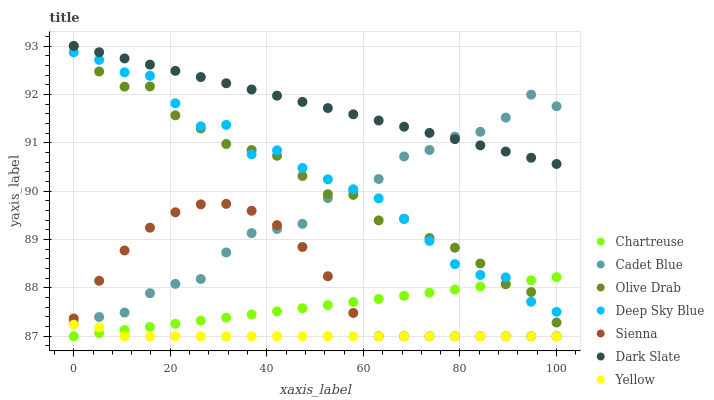Does Yellow have the minimum area under the curve?
Answer yes or no. Yes. Does Dark Slate have the maximum area under the curve?
Answer yes or no. Yes. Does Sienna have the minimum area under the curve?
Answer yes or no. No. Does Sienna have the maximum area under the curve?
Answer yes or no. No. Is Dark Slate the smoothest?
Answer yes or no. Yes. Is Olive Drab the roughest?
Answer yes or no. Yes. Is Yellow the smoothest?
Answer yes or no. No. Is Yellow the roughest?
Answer yes or no. No. Does Yellow have the lowest value?
Answer yes or no. Yes. Does Dark Slate have the lowest value?
Answer yes or no. No. Does Olive Drab have the highest value?
Answer yes or no. Yes. Does Sienna have the highest value?
Answer yes or no. No. Is Yellow less than Deep Sky Blue?
Answer yes or no. Yes. Is Dark Slate greater than Yellow?
Answer yes or no. Yes. Does Dark Slate intersect Cadet Blue?
Answer yes or no. Yes. Is Dark Slate less than Cadet Blue?
Answer yes or no. No. Is Dark Slate greater than Cadet Blue?
Answer yes or no. No. Does Yellow intersect Deep Sky Blue?
Answer yes or no. No. 